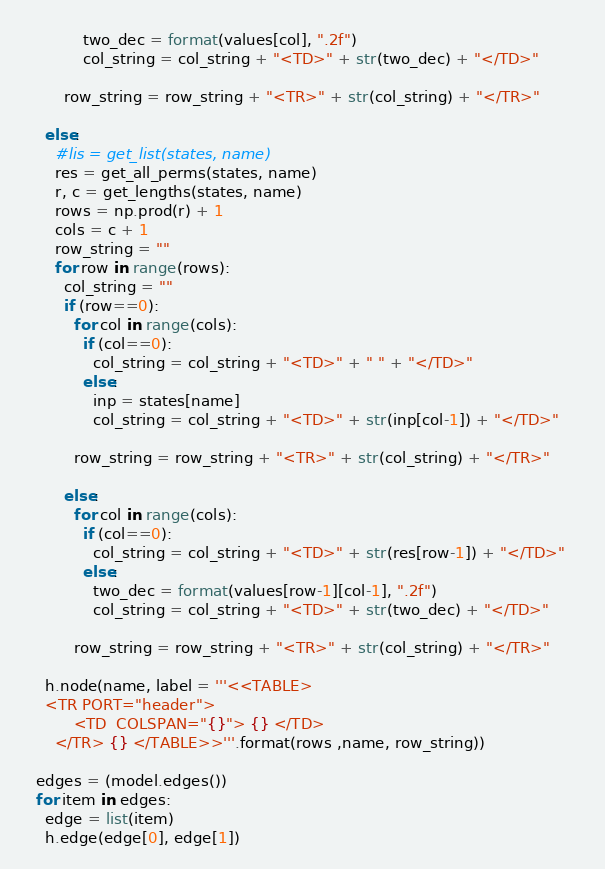Convert code to text. <code><loc_0><loc_0><loc_500><loc_500><_Python_>            two_dec = format(values[col], ".2f")
            col_string = col_string + "<TD>" + str(two_dec) + "</TD>" 

        row_string = row_string + "<TR>" + str(col_string) + "</TR>" 

    else:
      #lis = get_list(states, name)
      res = get_all_perms(states, name)
      r, c = get_lengths(states, name)
      rows = np.prod(r) + 1
      cols = c + 1
      row_string = ""
      for row in range(rows):
        col_string = ""
        if (row==0):
          for col in range(cols):
            if (col==0):
              col_string = col_string + "<TD>" + " " + "</TD>" 
            else:
              inp = states[name]
              col_string = col_string + "<TD>" + str(inp[col-1]) + "</TD>" 
          
          row_string = row_string + "<TR>" + str(col_string) + "</TR>" 

        else:
          for col in range(cols):
            if (col==0):
              col_string = col_string + "<TD>" + str(res[row-1]) + "</TD>"   
            else:
              two_dec = format(values[row-1][col-1], ".2f")
              col_string = col_string + "<TD>" + str(two_dec) + "</TD>" 
          
          row_string = row_string + "<TR>" + str(col_string) + "</TR>" 

    h.node(name, label = '''<<TABLE> 
    <TR PORT="header">
          <TD  COLSPAN="{}"> {} </TD>
      </TR> {} </TABLE>>'''.format(rows ,name, row_string))

  edges = (model.edges())
  for item in edges:
    edge = list(item)
    h.edge(edge[0], edge[1])
</code> 